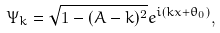Convert formula to latex. <formula><loc_0><loc_0><loc_500><loc_500>\Psi _ { k } = \sqrt { 1 - ( A - k ) ^ { 2 } } e ^ { i ( k x + \theta _ { 0 } ) } ,</formula> 